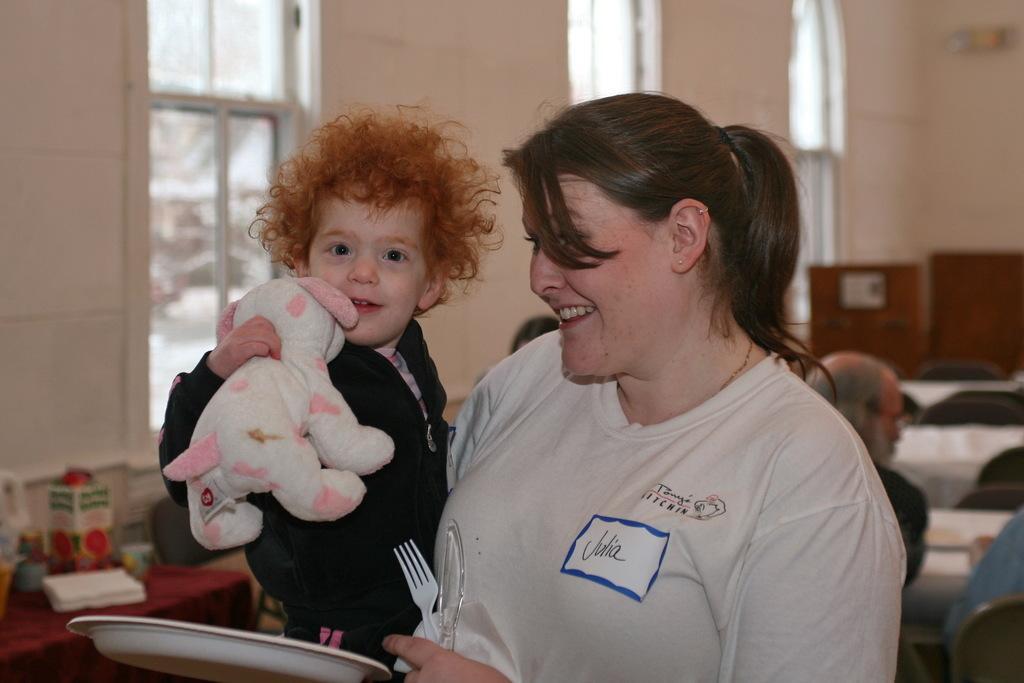In one or two sentences, can you explain what this image depicts? In this image in the front there are persons smiling and the woman is holding plate folk and a knife in her hand and there is a kid holding a toy and smiling. In the background there are persons, there are empty chairs, there are empty tables and there are windows. On the left side there is a table and on the table there are objects which are black, white and red in colour. 